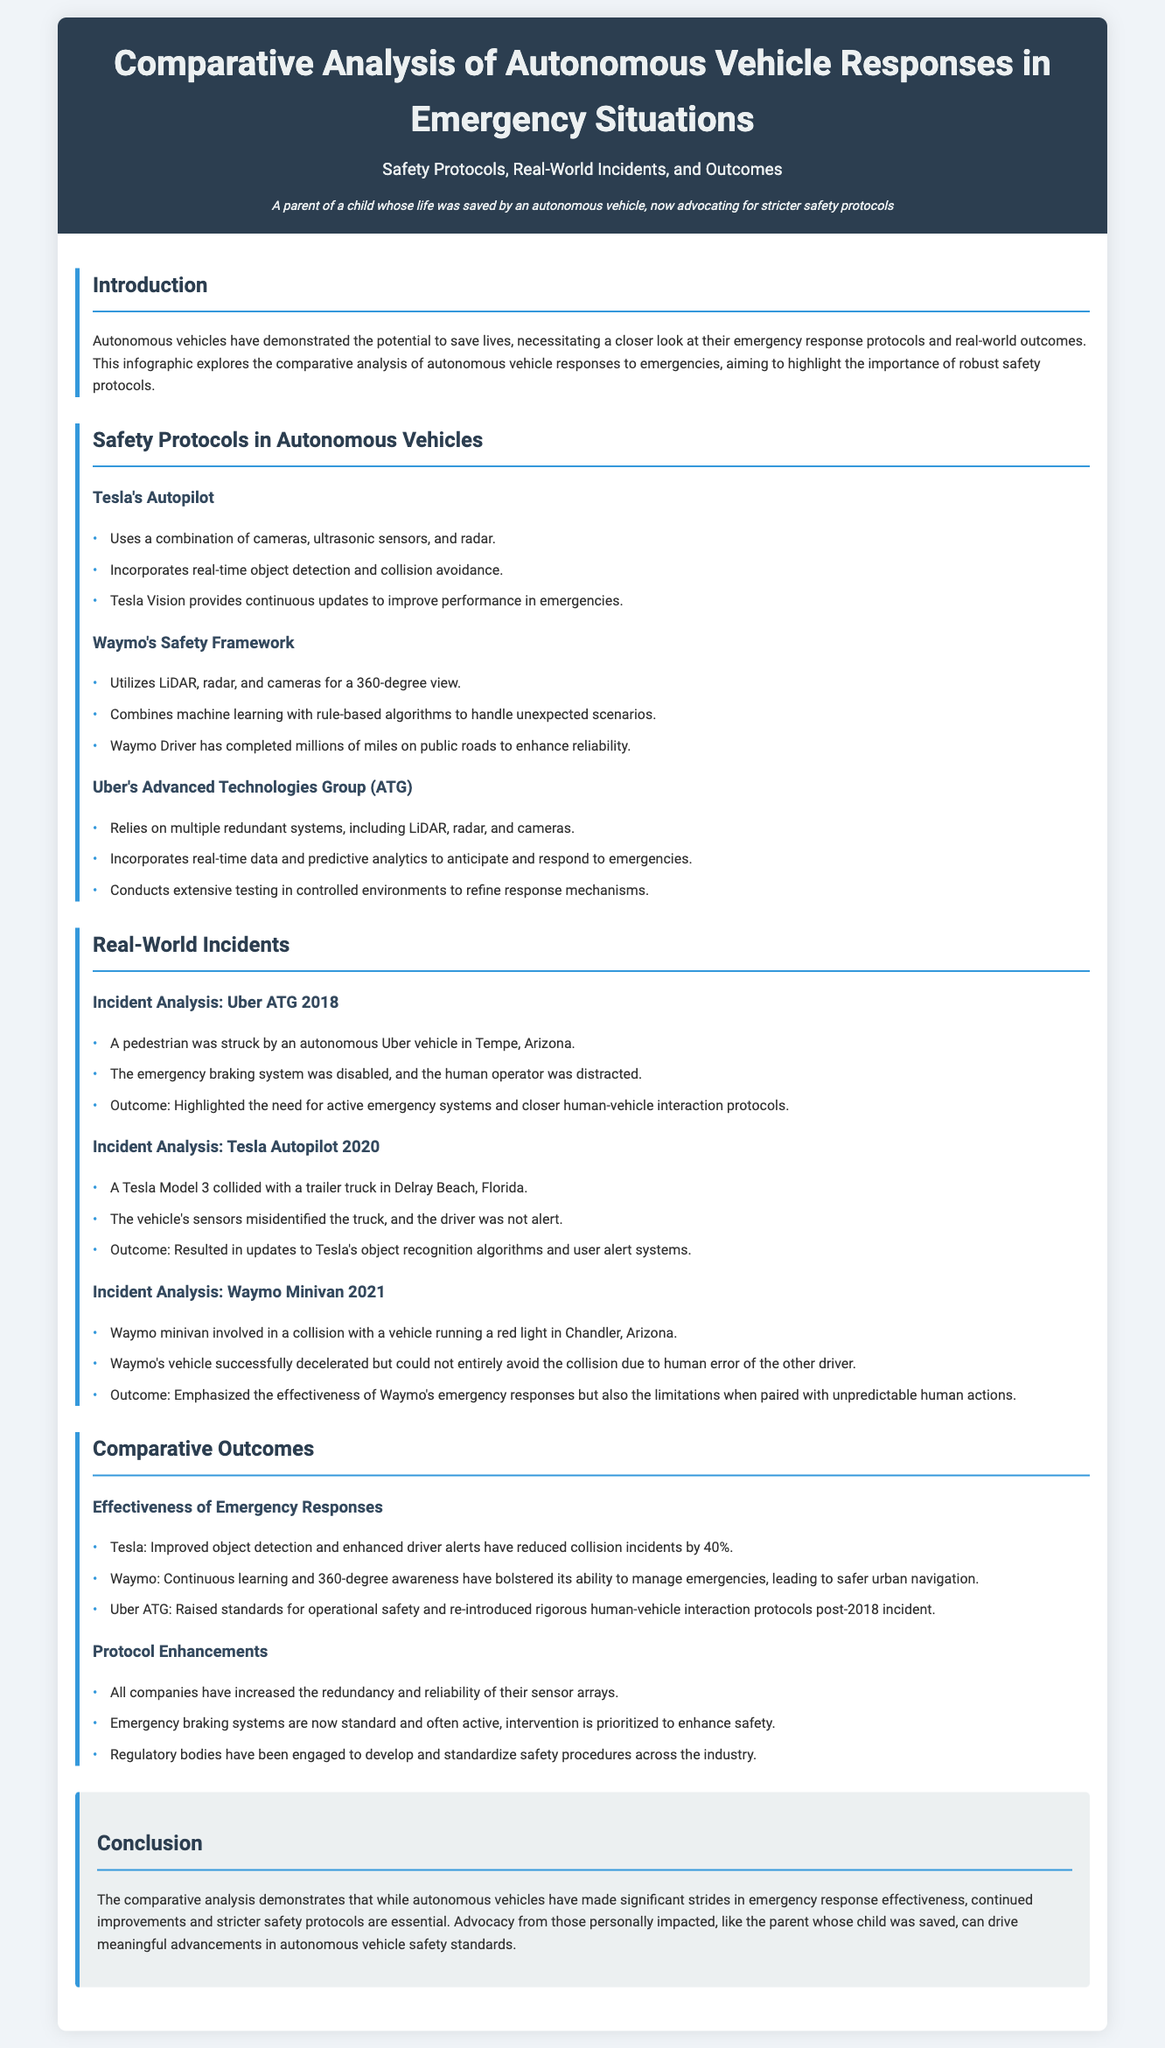What are the three components used by Tesla's Autopilot? The document lists cameras, ultrasonic sensors, and radar as the components used by Tesla's Autopilot.
Answer: cameras, ultrasonic sensors, and radar How much did Tesla reduce collision incidents by? According to the document, Tesla improved object detection and enhanced driver alerts, resulting in a 40% reduction in collision incidents.
Answer: 40% What year did the Uber ATG incident occur? The incident involving Uber's autonomous vehicle in Tempe, Arizona, was reported to have occurred in 2018.
Answer: 2018 Which company utilizes a 360-degree view for its safety framework? The document states that Waymo utilizes LiDAR, radar, and cameras for a 360-degree view.
Answer: Waymo What was a significant outcome of the Uber ATG incident in 2018? The document highlights that the incident underscored the need for active emergency systems and closer human-vehicle interaction protocols.
Answer: Active emergency systems and closer human-vehicle interaction protocols What emergency response capability does Waymo emphasize? The document mentions that Waymo emphasizes the effectiveness of its emergency responses, especially in managing emergencies.
Answer: Effectiveness of emergency responses Which autonomous vehicle system conducts extensive testing in controlled environments? The document indicates that Uber's Advanced Technologies Group (ATG) conducts extensive testing in controlled environments.
Answer: Uber's Advanced Technologies Group (ATG) What is the primary focus of the conclusion in the document? The conclusion emphasizes the importance of continued improvements and stricter safety protocols in autonomous vehicles.
Answer: Continued improvements and stricter safety protocols 